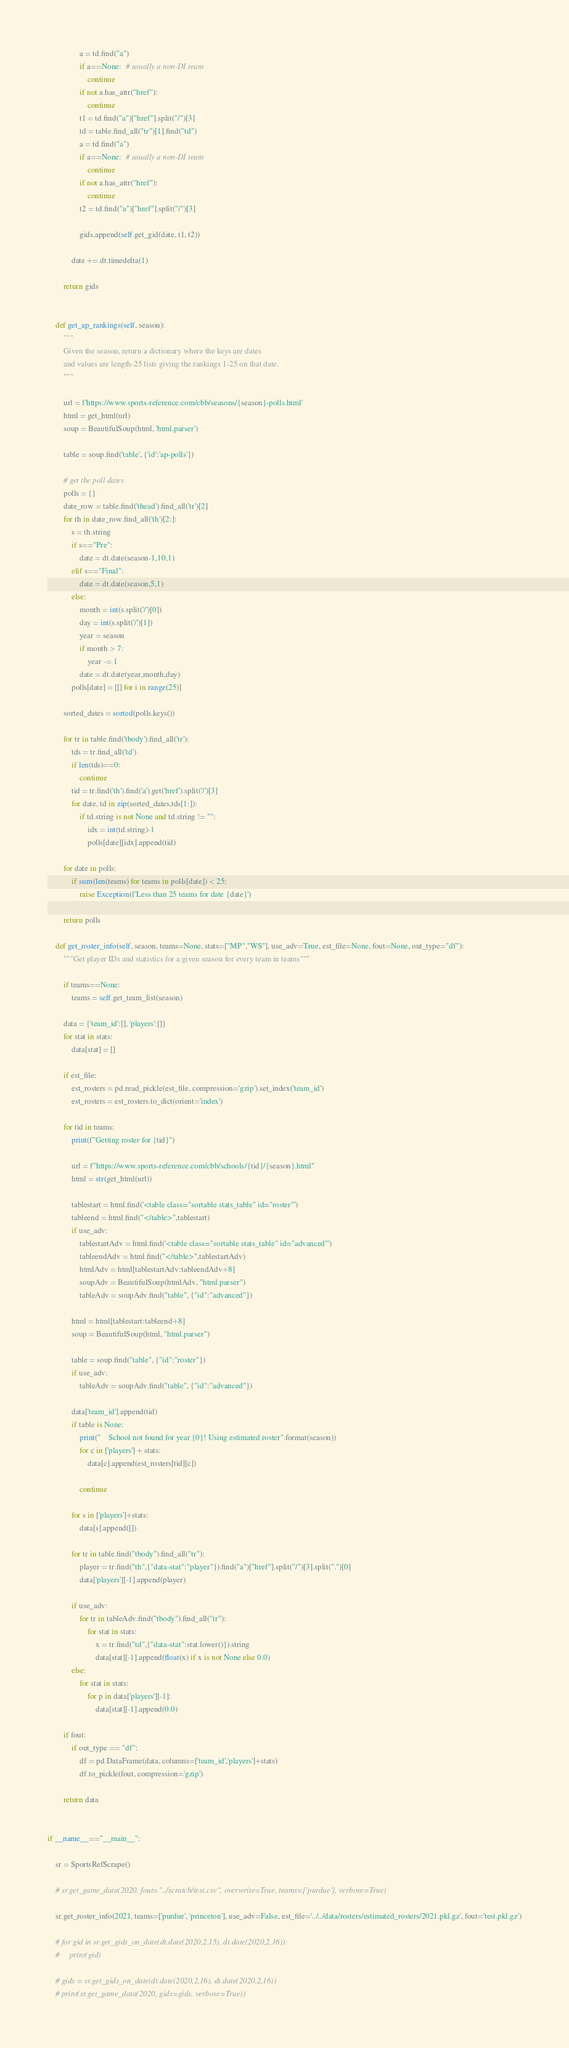Convert code to text. <code><loc_0><loc_0><loc_500><loc_500><_Python_>                a = td.find("a")
                if a==None:  # usually a non-DI team
                    continue
                if not a.has_attr("href"):
                    continue
                t1 = td.find("a")["href"].split("/")[3]
                td = table.find_all("tr")[1].find("td")
                a = td.find("a")
                if a==None:  # usually a non-DI team
                    continue
                if not a.has_attr("href"):
                    continue
                t2 = td.find("a")["href"].split("/")[3]
                
                gids.append(self.get_gid(date, t1, t2))

            date += dt.timedelta(1)

        return gids


    def get_ap_rankings(self, season):
        """
        Given the season, return a dictionary where the keys are dates 
        and values are length-25 lists giving the rankings 1-25 on that date.
        """

        url = f'https://www.sports-reference.com/cbb/seasons/{season}-polls.html'
        html = get_html(url)
        soup = BeautifulSoup(html, 'html.parser')

        table = soup.find('table', {'id':'ap-polls'})

        # get the poll dates
        polls = {}
        date_row = table.find('thead').find_all('tr')[2]
        for th in date_row.find_all('th')[2:]:
            s = th.string
            if s=="Pre":
                date = dt.date(season-1,10,1)
            elif s=="Final":
                date = dt.date(season,5,1)
            else:
                month = int(s.split('/')[0])
                day = int(s.split('/')[1])
                year = season
                if month > 7:
                    year -= 1
                date = dt.date(year,month,day)
            polls[date] = [[] for i in range(25)]

        sorted_dates = sorted(polls.keys())

        for tr in table.find('tbody').find_all('tr'):
            tds = tr.find_all('td')
            if len(tds)==0:
                continue
            tid = tr.find('th').find('a').get('href').split('/')[3]
            for date, td in zip(sorted_dates,tds[1:]):
                if td.string is not None and td.string != "":
                    idx = int(td.string)-1
                    polls[date][idx].append(tid)
                    
        for date in polls:
            if sum(len(teams) for teams in polls[date]) < 25:
                raise Exception(f'Less than 25 teams for date {date}')

        return polls

    def get_roster_info(self, season, teams=None, stats=["MP","WS"], use_adv=True, est_file=None, fout=None, out_type="df"):
        """Get player IDs and statistics for a given season for every team in teams"""

        if teams==None:
            teams = self.get_team_list(season)

        data = {'team_id':[], 'players':[]}
        for stat in stats:
            data[stat] = []

        if est_file:
            est_rosters = pd.read_pickle(est_file, compression='gzip').set_index('team_id')
            est_rosters = est_rosters.to_dict(orient='index')

        for tid in teams:
            print(f"Getting roster for {tid}")

            url = f"https://www.sports-reference.com/cbb/schools/{tid}/{season}.html"
            html = str(get_html(url))

            tablestart = html.find('<table class="sortable stats_table" id="roster"')
            tableend = html.find("</table>",tablestart)
            if use_adv:
                tablestartAdv = html.find('<table class="sortable stats_table" id="advanced"')
                tableendAdv = html.find("</table>",tablestartAdv)
                htmlAdv = html[tablestartAdv:tableendAdv+8]
                soupAdv = BeautifulSoup(htmlAdv, "html.parser")
                tableAdv = soupAdv.find("table", {"id":"advanced"})

            html = html[tablestart:tableend+8]
            soup = BeautifulSoup(html, "html.parser")
            
            table = soup.find("table", {"id":"roster"})
            if use_adv:
                tableAdv = soupAdv.find("table", {"id":"advanced"})

            data['team_id'].append(tid)
            if table is None:
                print("    School not found for year {0}! Using estimated roster".format(season))
                for c in ['players'] + stats:
                    data[c].append(est_rosters[tid][c])

                continue
                
            for s in ['players']+stats:
                data[s].append([])
                
            for tr in table.find("tbody").find_all("tr"):        
                player = tr.find("th",{"data-stat":"player"}).find("a")["href"].split("/")[3].split(".")[0]
                data['players'][-1].append(player)

            if use_adv:
                for tr in tableAdv.find("tbody").find_all("tr"):
                    for stat in stats:
                        x = tr.find("td",{"data-stat":stat.lower()}).string
                        data[stat][-1].append(float(x) if x is not None else 0.0)
            else:
                for stat in stats:
                    for p in data['players'][-1]:
                        data[stat][-1].append(0.0)

        if fout:
            if out_type == "df":
                df = pd.DataFrame(data, columns=['team_id','players']+stats)
                df.to_pickle(fout, compression='gzip')

        return data


if __name__=="__main__":
    
    sr = SportsRefScrape()

    # sr.get_game_data(2020, fout="../scratch/test.csv", overwrite=True, teams=['purdue'], verbose=True)

    sr.get_roster_info(2021, teams=['purdue', 'princeton'], use_adv=False, est_file='../../data/rosters/estimated_rosters/2021.pkl.gz', fout='test.pkl.gz')

    # for gid in sr.get_gids_on_date(dt.date(2020,2,15), dt.date(2020,2,16)):
    #     print(gid)
    
    # gids = sr.get_gids_on_date(dt.date(2020,2,16), dt.date(2020,2,16))
    # print(sr.get_game_data(2020, gids=gids, verbose=True))
</code> 